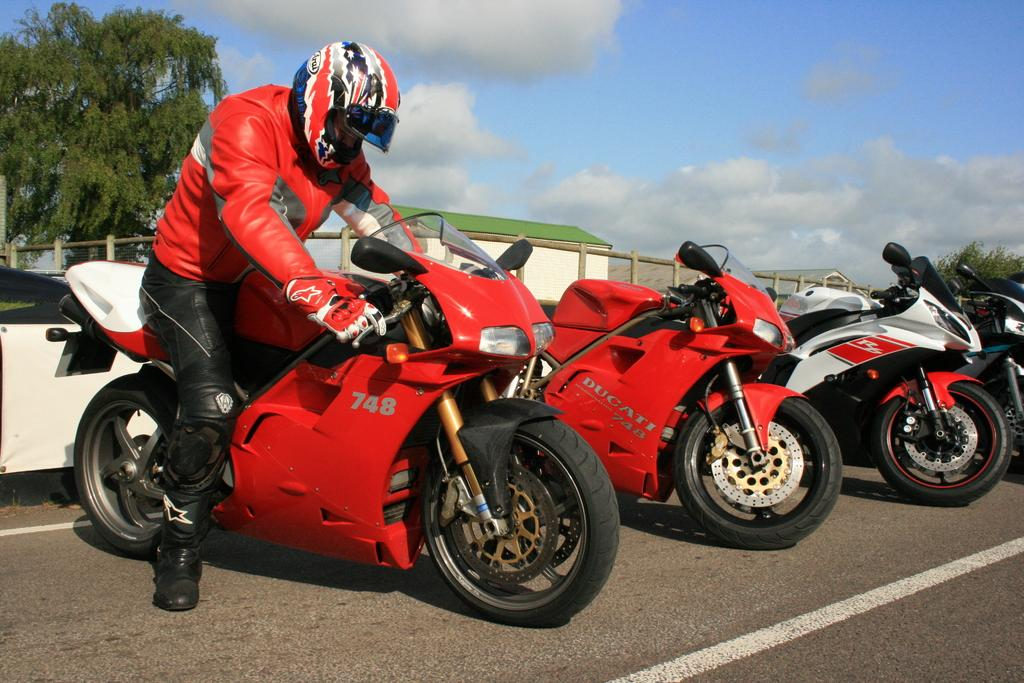What type of vehicles are in the image? There are bikes in the image. What is the person in the image doing? One person is sitting on a bike. What can be seen in the background of the image? There are houses, fencing, trees, and the sky visible in the image. What type of twig is being used as a key to unlock the bike in the image? There is no twig or key present in the image; the person is simply sitting on the bike. 